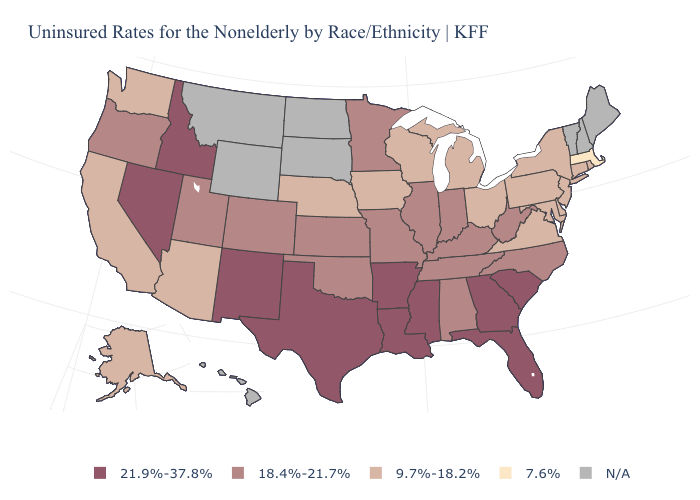Which states have the highest value in the USA?
Quick response, please. Arkansas, Florida, Georgia, Idaho, Louisiana, Mississippi, Nevada, New Mexico, South Carolina, Texas. What is the value of Maryland?
Give a very brief answer. 9.7%-18.2%. Name the states that have a value in the range 9.7%-18.2%?
Answer briefly. Alaska, Arizona, California, Connecticut, Delaware, Iowa, Maryland, Michigan, Nebraska, New Jersey, New York, Ohio, Pennsylvania, Rhode Island, Virginia, Washington, Wisconsin. Which states have the highest value in the USA?
Concise answer only. Arkansas, Florida, Georgia, Idaho, Louisiana, Mississippi, Nevada, New Mexico, South Carolina, Texas. What is the value of South Dakota?
Short answer required. N/A. Name the states that have a value in the range 21.9%-37.8%?
Short answer required. Arkansas, Florida, Georgia, Idaho, Louisiana, Mississippi, Nevada, New Mexico, South Carolina, Texas. Among the states that border Pennsylvania , which have the highest value?
Give a very brief answer. West Virginia. What is the highest value in the USA?
Keep it brief. 21.9%-37.8%. How many symbols are there in the legend?
Keep it brief. 5. What is the value of Connecticut?
Be succinct. 9.7%-18.2%. What is the lowest value in the USA?
Short answer required. 7.6%. Is the legend a continuous bar?
Write a very short answer. No. What is the value of Kentucky?
Quick response, please. 18.4%-21.7%. Name the states that have a value in the range 21.9%-37.8%?
Keep it brief. Arkansas, Florida, Georgia, Idaho, Louisiana, Mississippi, Nevada, New Mexico, South Carolina, Texas. Does the map have missing data?
Be succinct. Yes. 